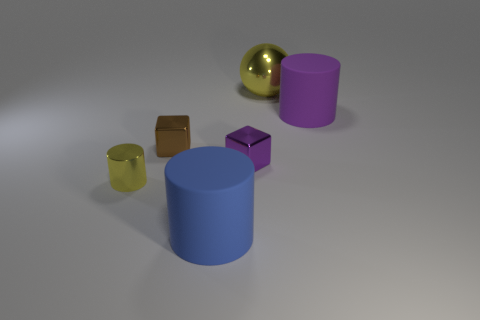Could you describe the lighting and shadows in the scene? The scene is illuminated with a soft, diffused lighting from above that creates gentle shadows under the objects. This lighting accentuates the three-dimensionality of the geometric shapes and casts their silhouettes subtly onto the neutral gray surface they rest upon. Could the lighting indicate the time of day if this were outdoors? If the setting were outdoors, the softness and angle of the shadows might suggest an overcast day or a time when the sun is not at its peak, such as during the early morning or late afternoon. However, the environment suggests an indoor scene with controlled lighting rather than natural sunlight. 